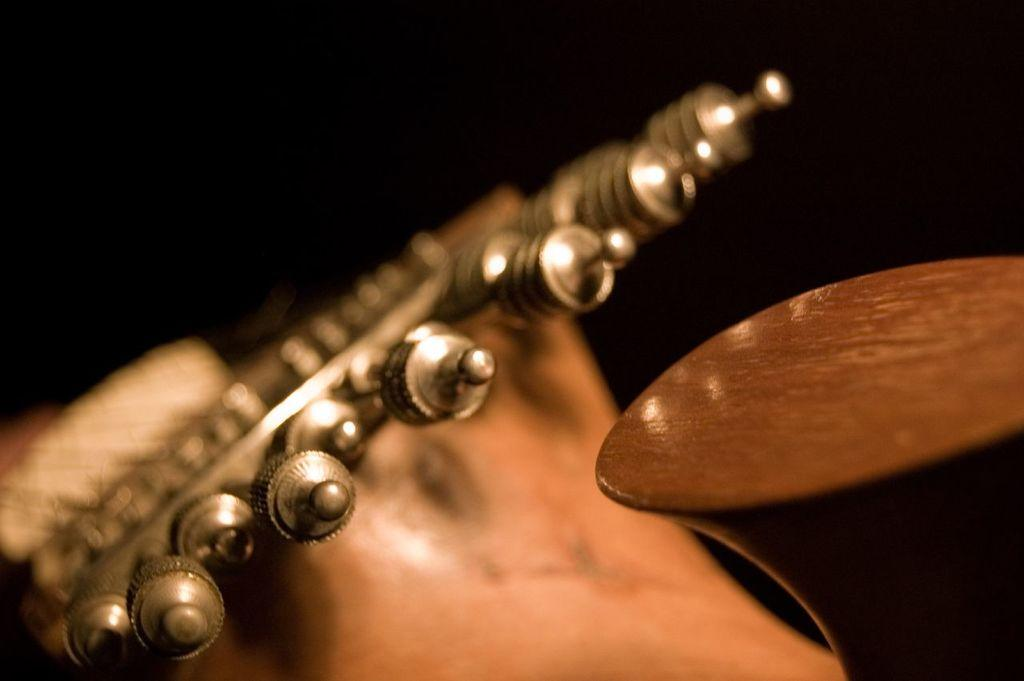What type of image is being shown? The image is a macro image. What can be seen in the macro image? There is an object in the image that resembles a musical instrument. How many kittens are playing with the bone in the image? There are no kittens or bones present in the image. 